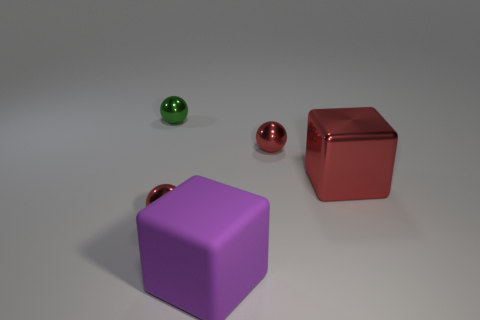What number of other objects have the same material as the big purple object?
Provide a short and direct response. 0. The rubber object that is the same shape as the large metallic object is what size?
Your response must be concise. Large. There is a tiny green metallic object; are there any small green objects to the left of it?
Offer a very short reply. No. What material is the purple object?
Provide a short and direct response. Rubber. Do the big cube on the left side of the large red object and the big metal cube have the same color?
Provide a succinct answer. No. Are there any other things that are the same shape as the tiny green metal thing?
Your answer should be very brief. Yes. The large shiny object that is the same shape as the matte object is what color?
Your response must be concise. Red. There is a red sphere behind the large red metal object; what material is it?
Make the answer very short. Metal. What is the color of the matte thing?
Provide a succinct answer. Purple. There is a red metal thing that is to the left of the purple object; does it have the same size as the green sphere?
Give a very brief answer. Yes. 